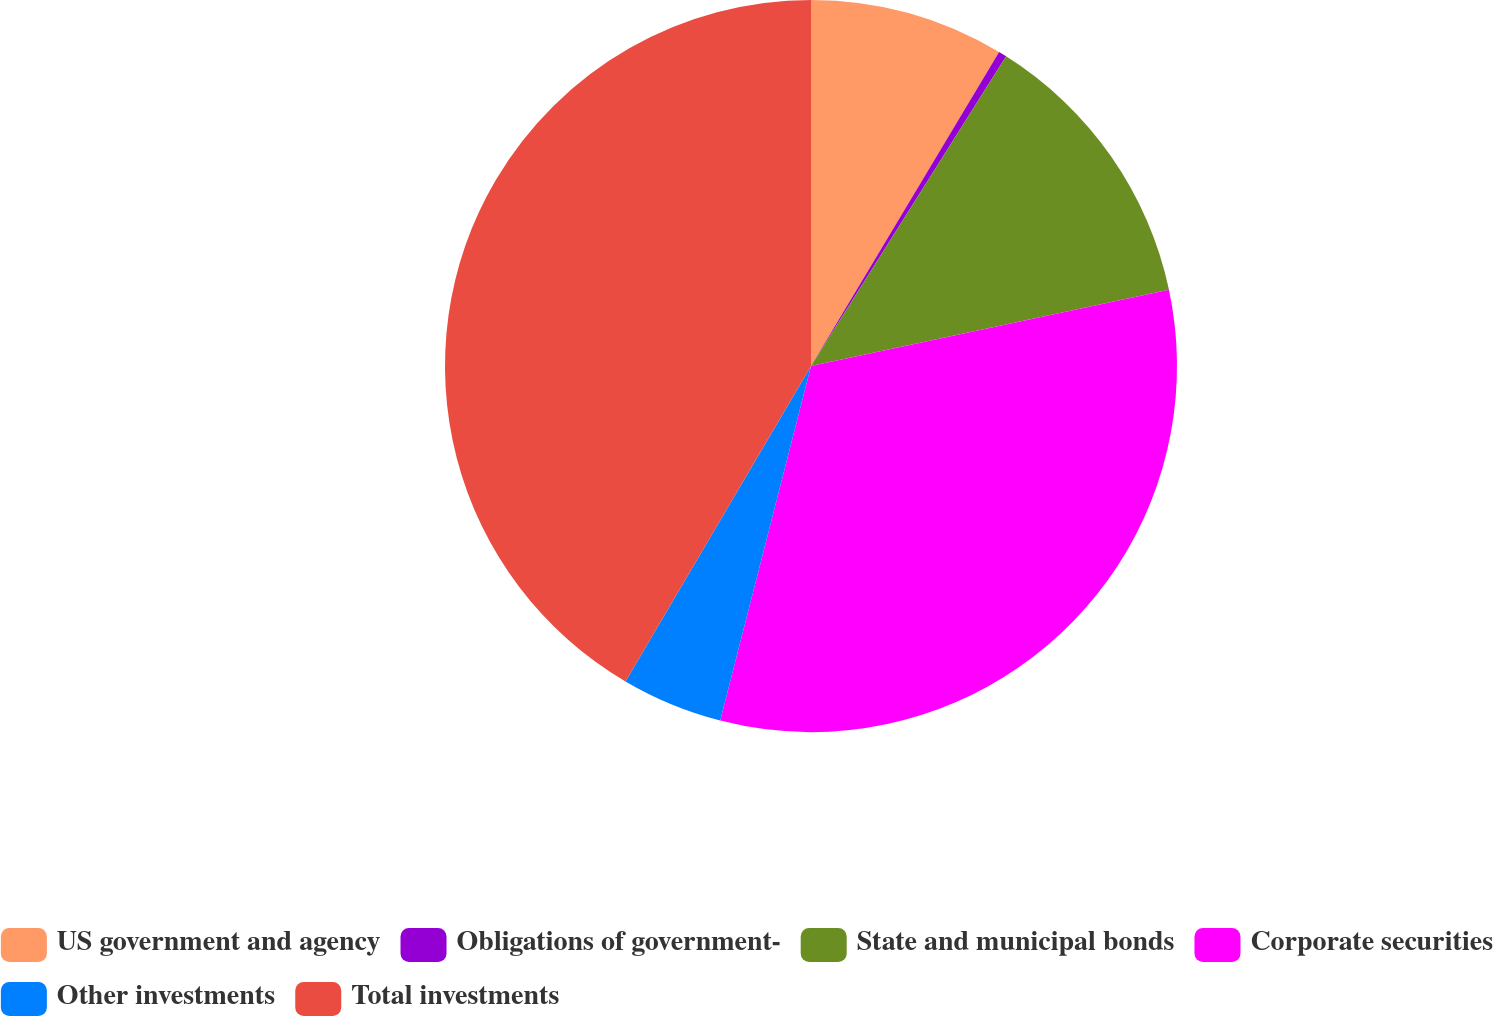<chart> <loc_0><loc_0><loc_500><loc_500><pie_chart><fcel>US government and agency<fcel>Obligations of government-<fcel>State and municipal bonds<fcel>Corporate securities<fcel>Other investments<fcel>Total investments<nl><fcel>8.59%<fcel>0.36%<fcel>12.71%<fcel>32.33%<fcel>4.47%<fcel>41.54%<nl></chart> 